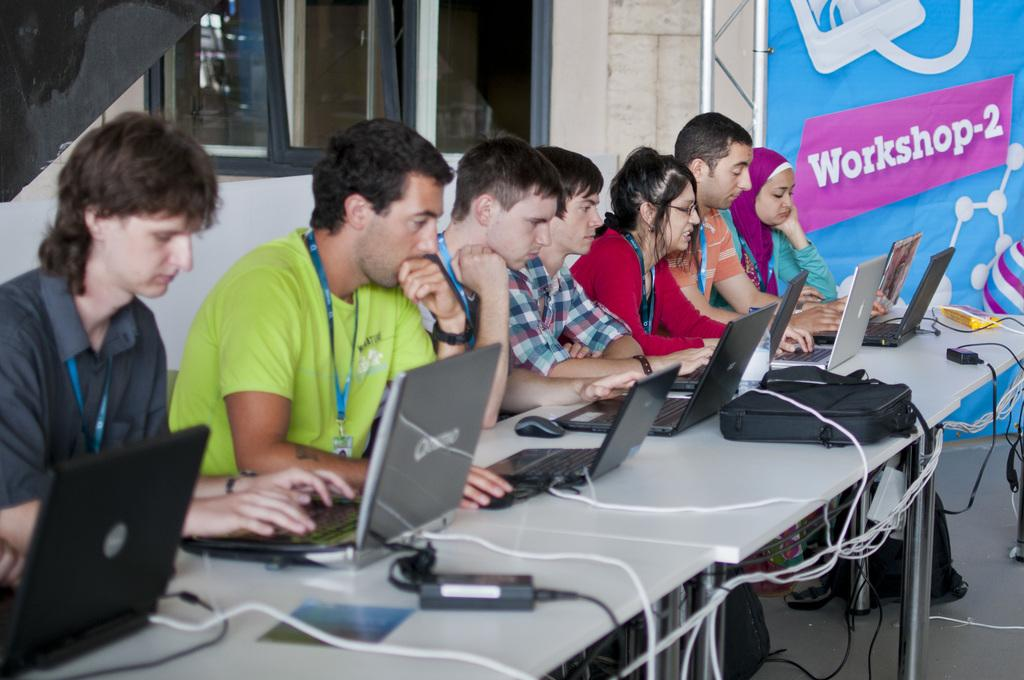What type of furniture can be seen in the image? There are tables in the image. What electronic devices are visible in the image? Laptops are visible in the image. What are the people using to interact with the laptops? Mouses are in the image for interacting with the laptops. What might the people be carrying with them? Bags are present in the image. What is the position of the people in the image? People are sitting in the image. What can be seen on the right side of the image? There is a banner on the right side of the image. What is visible in the background of the image? There are windows in the background of the image. What type of beef is being served at the event in the image? There is no beef present in the image; it features tables, laptops, mouses, bags, people sitting, a banner, and windows in the background. What type of soda can be seen in the hands of the people in the image? There is no soda present in the image; it only shows tables, laptops, mouses, bags, people sitting, a banner, and windows in the background. 